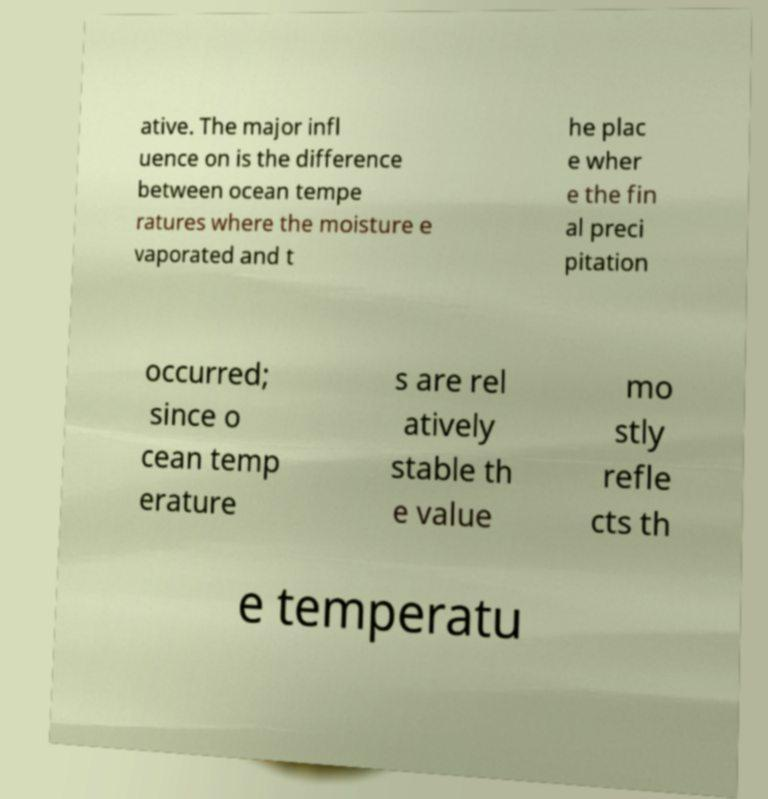Could you assist in decoding the text presented in this image and type it out clearly? ative. The major infl uence on is the difference between ocean tempe ratures where the moisture e vaporated and t he plac e wher e the fin al preci pitation occurred; since o cean temp erature s are rel atively stable th e value mo stly refle cts th e temperatu 